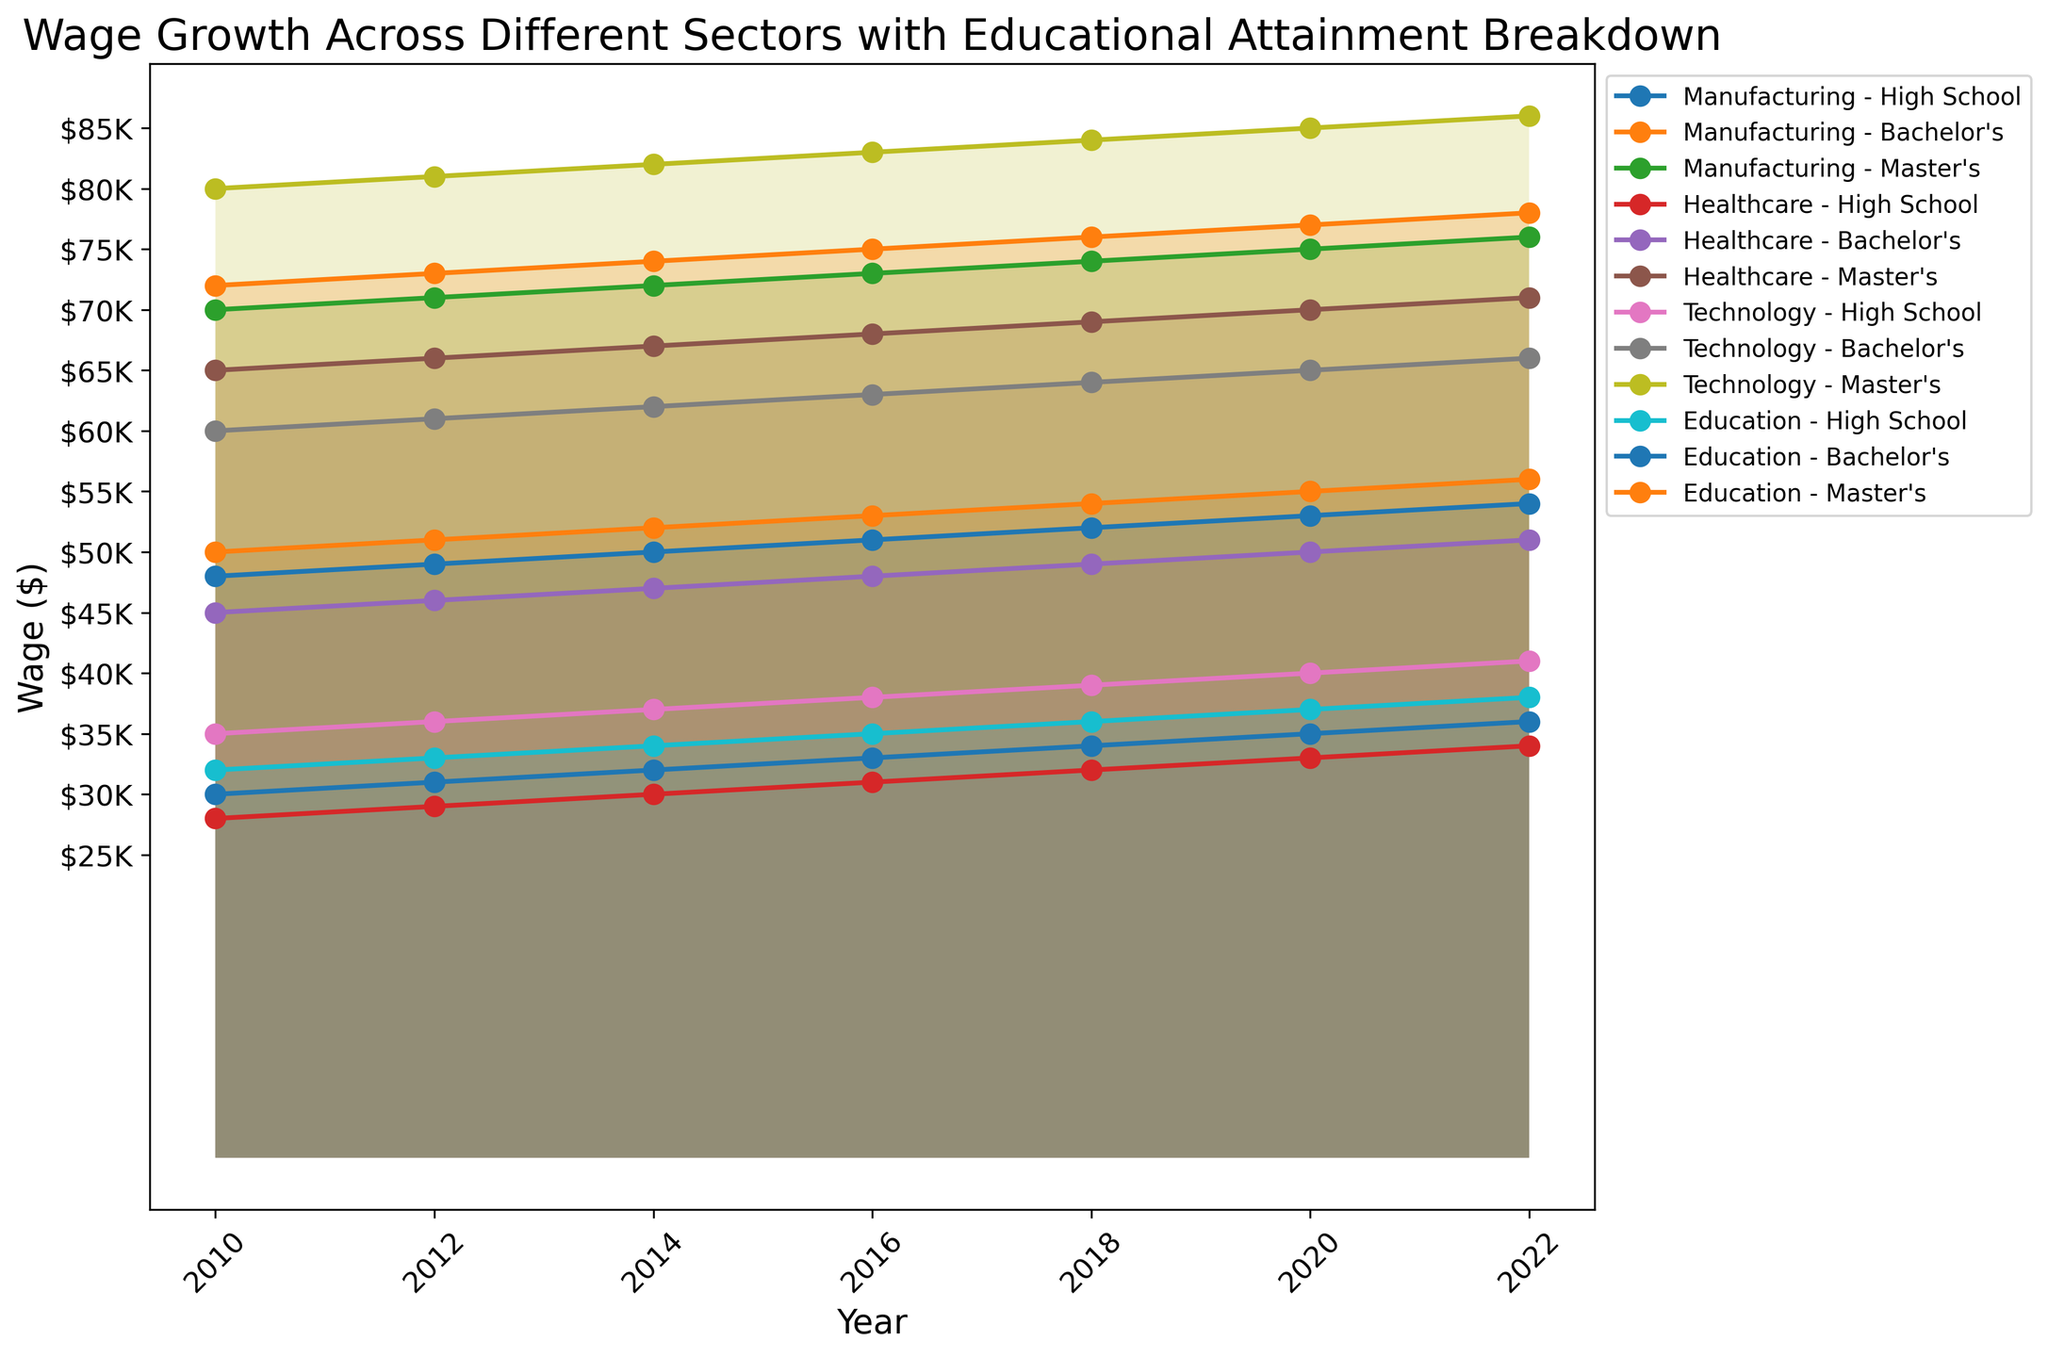What is the overall trend in wages for the Technology sector? The line chart shows the wages for the Technology sector from 2010 to 2022. Wages increase for all education levels over the years, indicating an upward trend.
Answer: Upward trend Which sector had the highest wage for Master's degree holders in 2020? Identify the lines representing Master's degree holders and look for the highest peak among them in 2020. The Technology sector has the highest peak at that point.
Answer: Technology By how much did the wage for Bachelor's degree holders in the Healthcare sector increase from 2010 to 2022? Subtract the 2010 wage of $45000 from the 2022 wage of $51000 for Bachelor's degree holders in the Healthcare sector. The increase is $51000 - $45000 = $6000.
Answer: $6000 Between 2014 and 2016, which sector saw the largest wage growth for High School diploma holders? Analyze the slope of the lines representing High School diploma holders between 2014 and 2016. Technology shows the largest increase, from $37000 to $38000.
Answer: Technology What is the wage difference between Bachelor's and High School degree holders in the Manufacturing sector in 2022? Subtract the 2022 wage of High School diploma holders ($36000) from that of Bachelor's degree holders ($56000) in Manufacturing. The difference is $56000 - $36000 = $20000.
Answer: $20000 Which education level exhibits the least wage growth in the Healthcare sector from 2010 to 2022? Compare the changes in wages from 2010 to 2022 for each education level in Healthcare. High School shows the smallest increase from $28000 to $34000, a growth of $6000.
Answer: High School In 2018, how do the wages for Master's degree holders in Education compare to Bachelor's degree holders in Technology? Identify the corresponding points on the plot for Master’s in Education ($76000) and Bachelor’s in Technology ($64000) in 2018. Master’s in Education is higher by $12000.
Answer: Master's in Education is higher What is the average wage for Bachelor's degree holders in the Technology sector over the years? Sum the wages for Bachelor's degree holders in Technology from 2010 to 2022 ($35000, $36000, $37000, $38000, $39000, $40000, $41000) and divide by the number of years (7). The average is ($35000 + $36000 + $37000 + $38000 + $39000 + $40000 + $41000)/7 = $66357.14.
Answer: $66357.14 